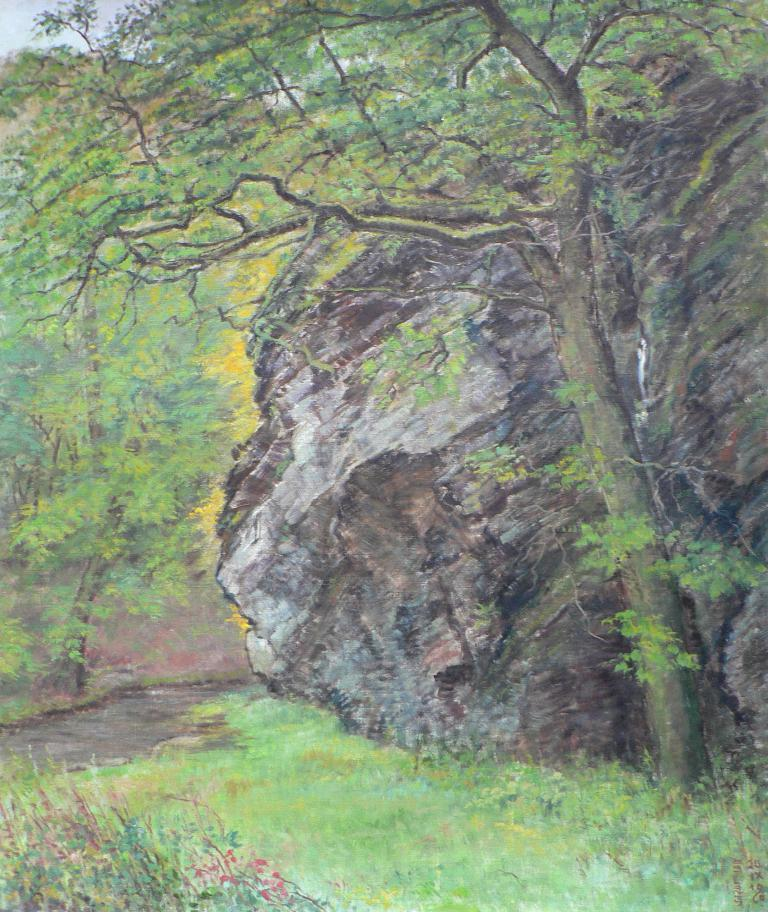What type of natural elements are present in the painting? The painting contains trees, a rock, and grass. What part of the sky can be seen in the painting? The sky is visible in the top left corner of the image. What substance is being used by the father and sister in the painting? There is no father, sister, or substance present in the painting; it only contains trees, a rock, grass, and the sky. 